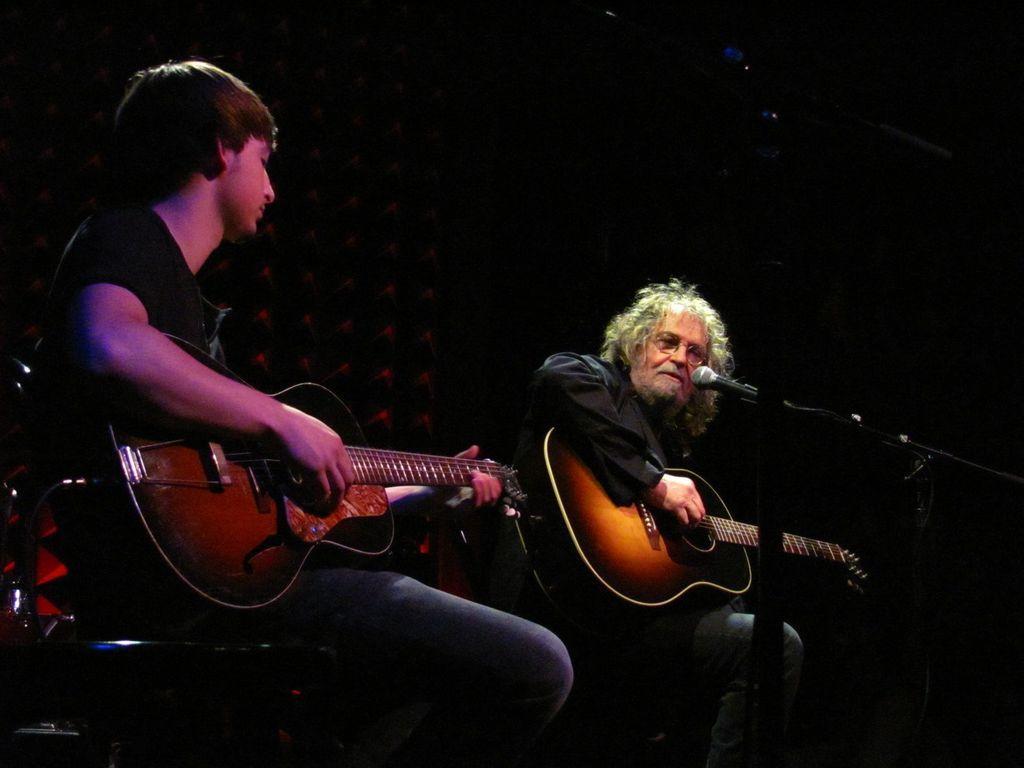In one or two sentences, can you explain what this image depicts? There are two men sitting in a chair, holding guitars, in their hands. One of the guy is having a microphone in front of him. And there is dark light in the background. 